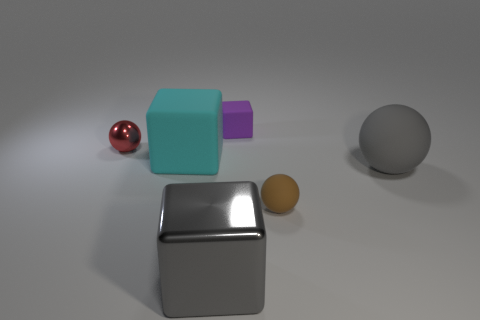There is a cube that is the same color as the big rubber sphere; what is its material?
Make the answer very short. Metal. Is the material of the thing behind the tiny metal thing the same as the small red object?
Give a very brief answer. No. Are there any things that are on the left side of the rubber sphere that is to the right of the tiny sphere in front of the red shiny sphere?
Provide a short and direct response. Yes. How many blocks are purple things or red things?
Provide a short and direct response. 1. There is a gray object that is on the left side of the small purple block; what material is it?
Keep it short and to the point. Metal. Do the metallic thing on the right side of the tiny red ball and the sphere on the right side of the brown object have the same color?
Give a very brief answer. Yes. How many objects are either big gray balls or brown objects?
Offer a very short reply. 2. What number of other things are the same shape as the cyan matte object?
Offer a very short reply. 2. Does the cube that is right of the big gray cube have the same material as the small sphere that is on the left side of the large gray metallic cube?
Provide a short and direct response. No. The object that is left of the purple block and in front of the large gray matte ball has what shape?
Provide a short and direct response. Cube. 